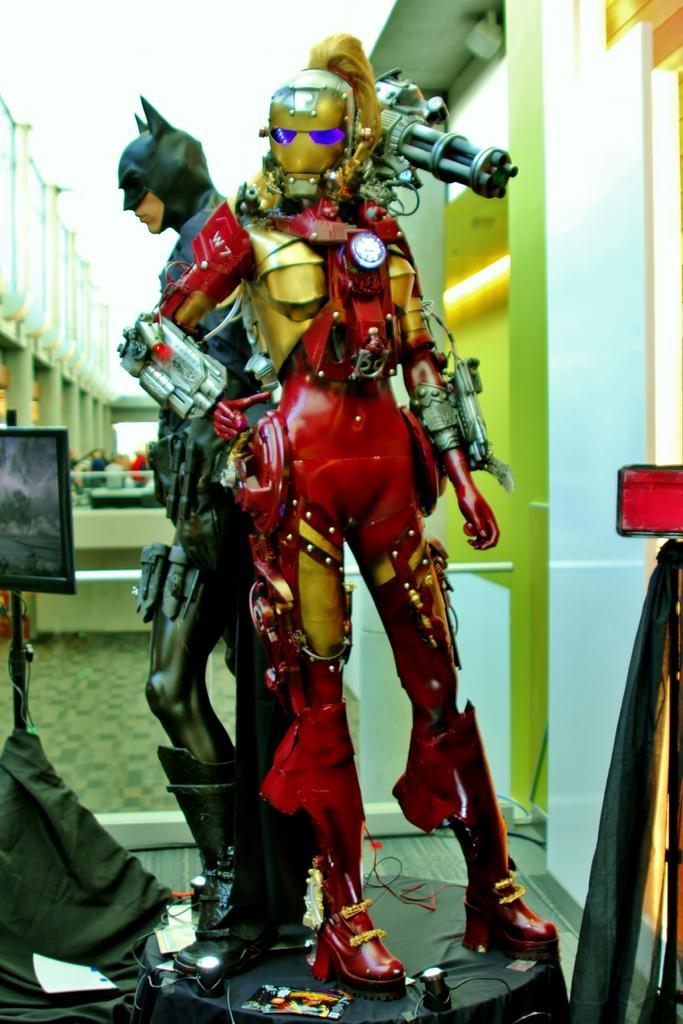In one or two sentences, can you explain what this image depicts? These are the 2 dolls in the shape of an iron man and a bat man. On the left side there is an electronic display in this image. 